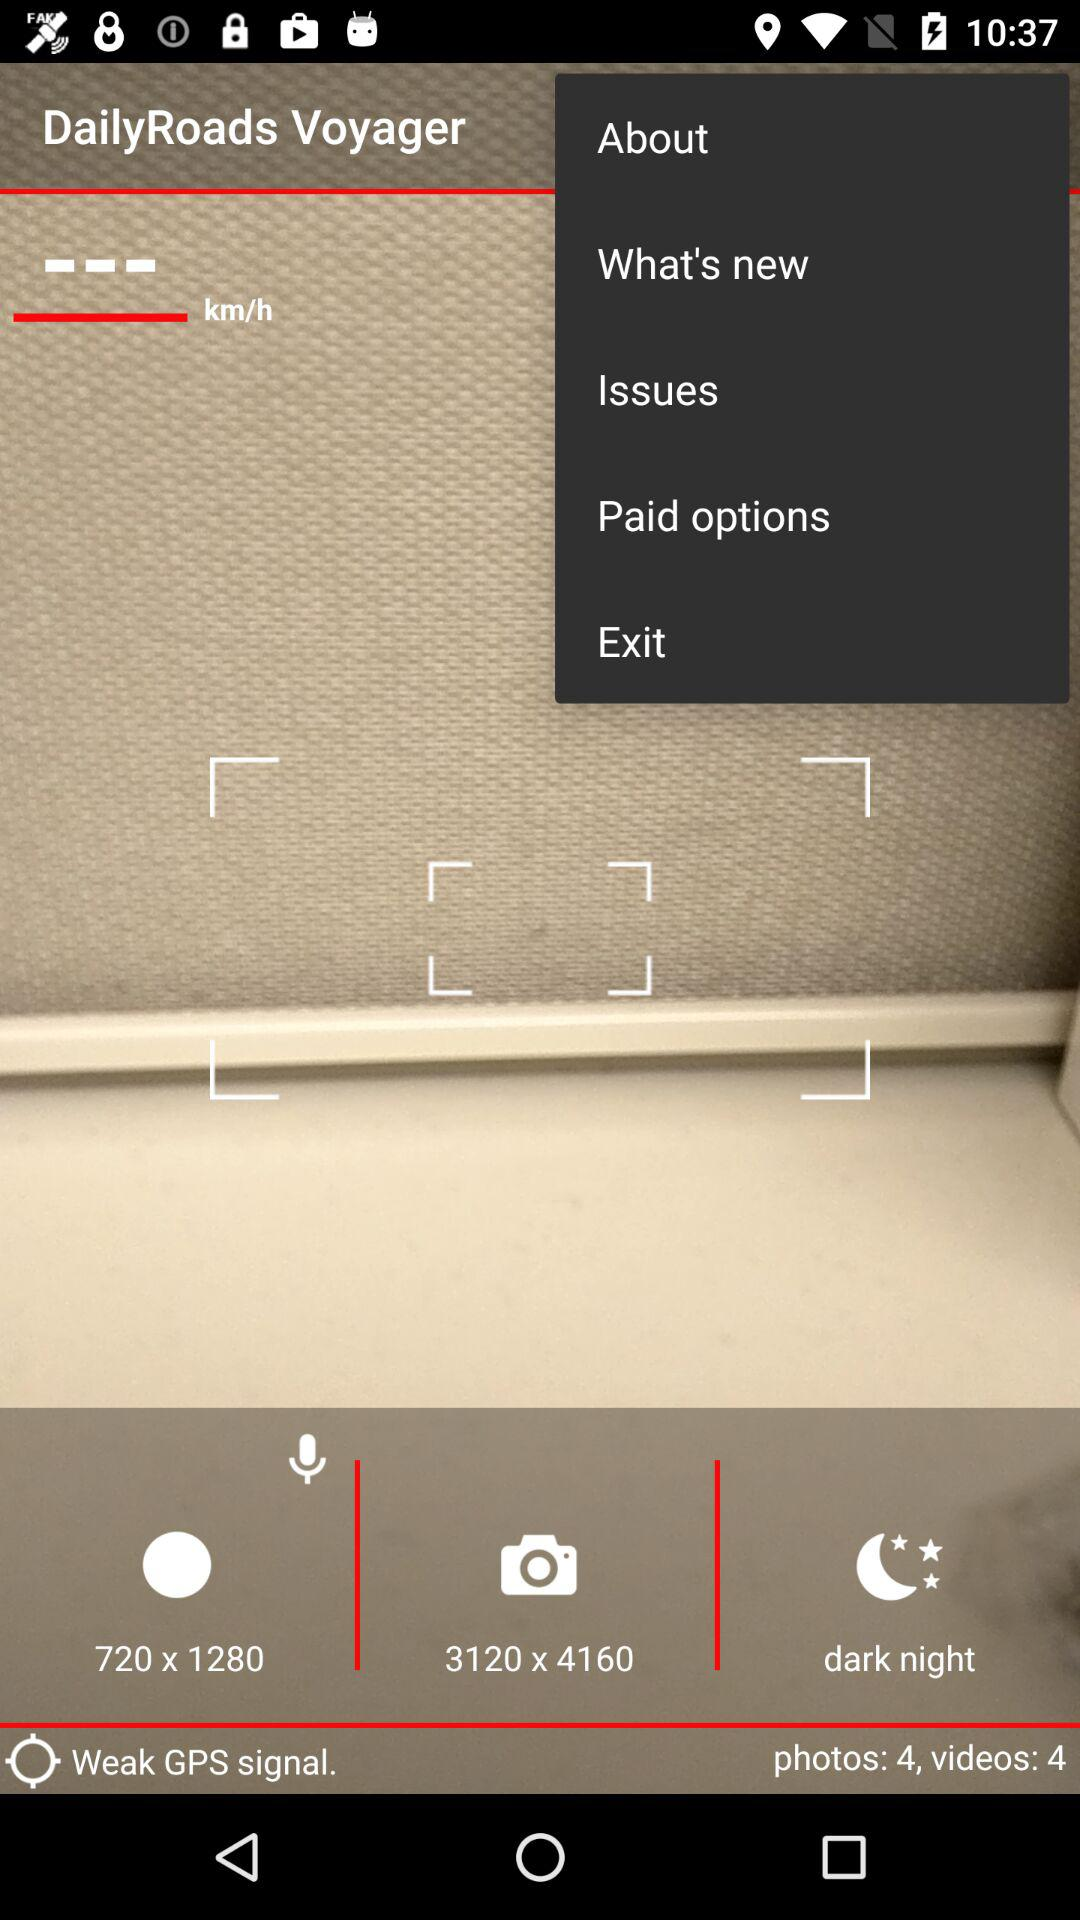How many more photos than videos are there?
Answer the question using a single word or phrase. 0 